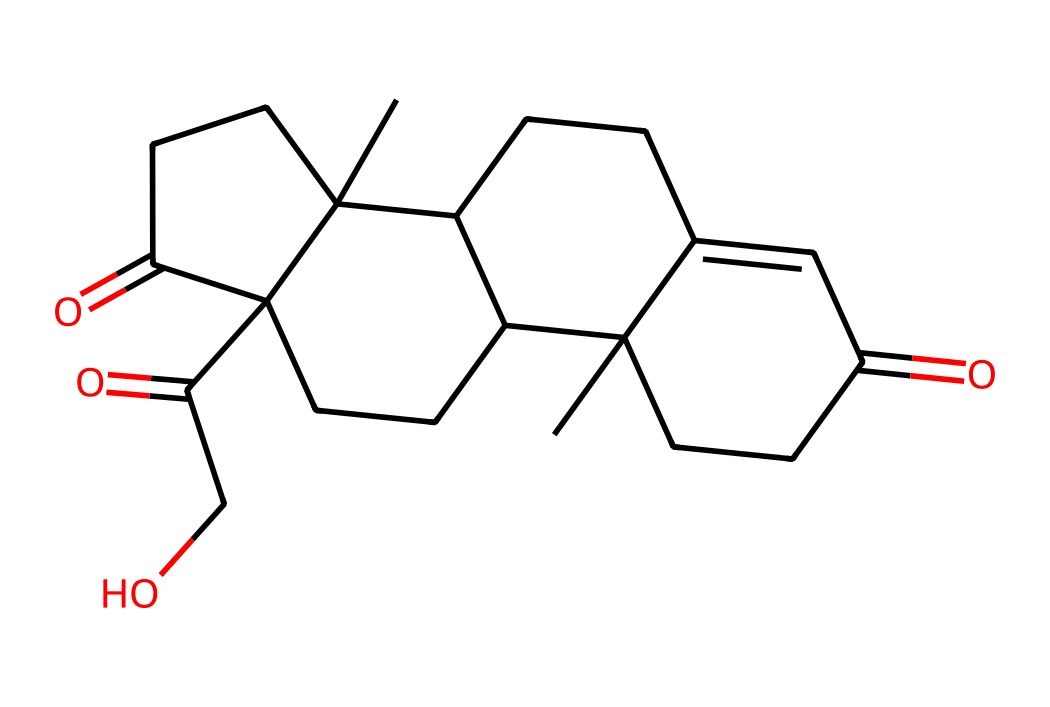What is the IUPAC name of this chemical? The SMILES representation indicates the arrangement of atoms, and analyzing the structure reveals that it corresponds to the compound known as cortisone, which is a specific type of corticosteroid hormone.
Answer: cortisone How many carbon atoms are present in this structure? In the SMILES representation, each "C" denotes a carbon atom. By counting all the carbon atoms in the structure, we find that there are 21 carbon atoms present.
Answer: 21 How many functional groups can be identified in this molecule? Upon examining the structure for distinct functional groups, we can identify three carbonyl groups (C=O), indicating that there are three functional groups based on the presence of keto groups.
Answer: 3 What type of molecule is cortisol classified as? Given the structure and the presence of multiple carbon rings and functional groups, cortisol is classified as a steroid hormone.
Answer: steroid hormone How many rings are present in the chemical structure of cortisol? By analyzing the SMILES representation, we can identify four fused rings, which is typical for steroid structures like cortisol.
Answer: 4 What is the molecular weight of cortisol? By determining the composition of all the atoms in the structure and using their atomic weights, the molecular weight of cortisol can be calculated, which is approximately 362.47 g/mol.
Answer: 362.47 g/mol 